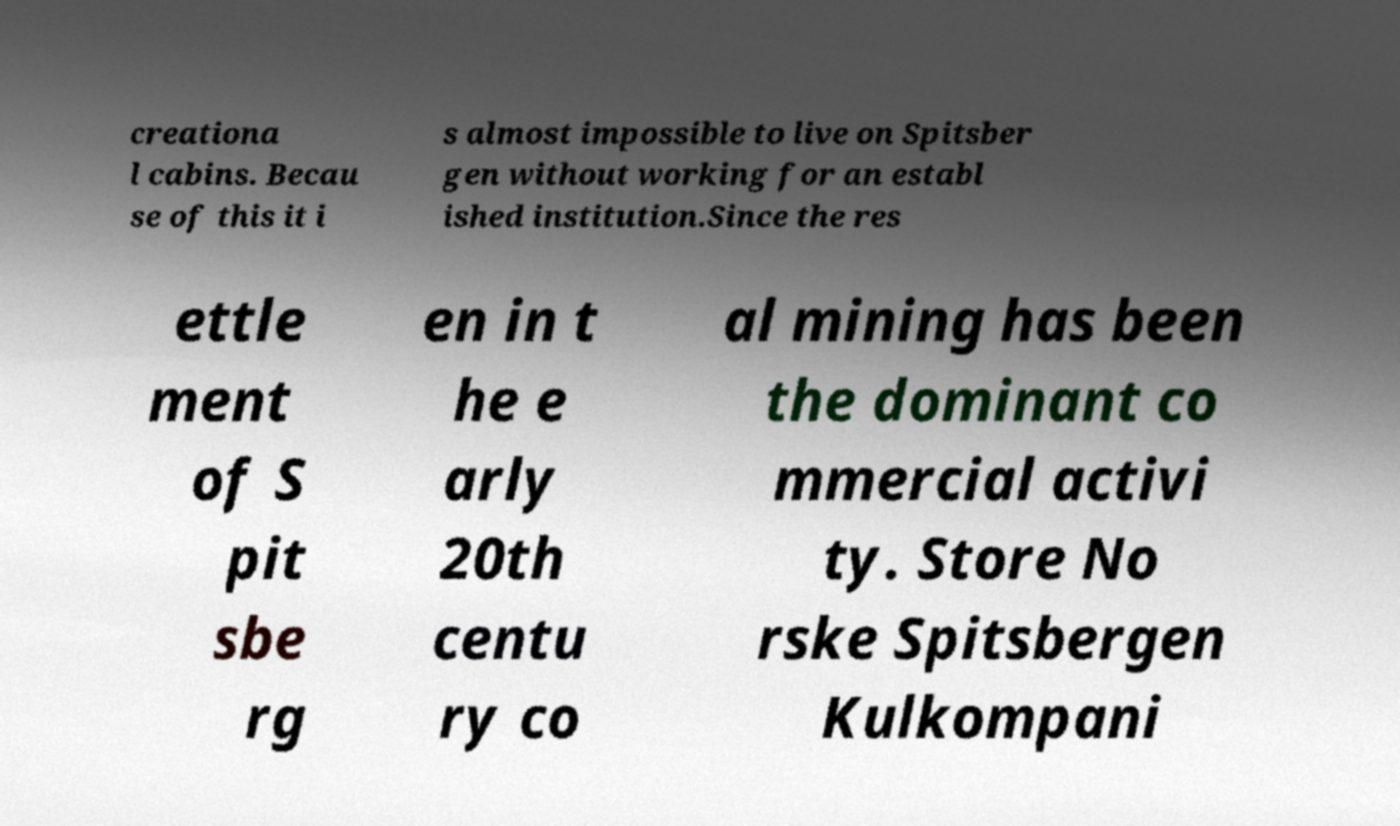Could you extract and type out the text from this image? creationa l cabins. Becau se of this it i s almost impossible to live on Spitsber gen without working for an establ ished institution.Since the res ettle ment of S pit sbe rg en in t he e arly 20th centu ry co al mining has been the dominant co mmercial activi ty. Store No rske Spitsbergen Kulkompani 